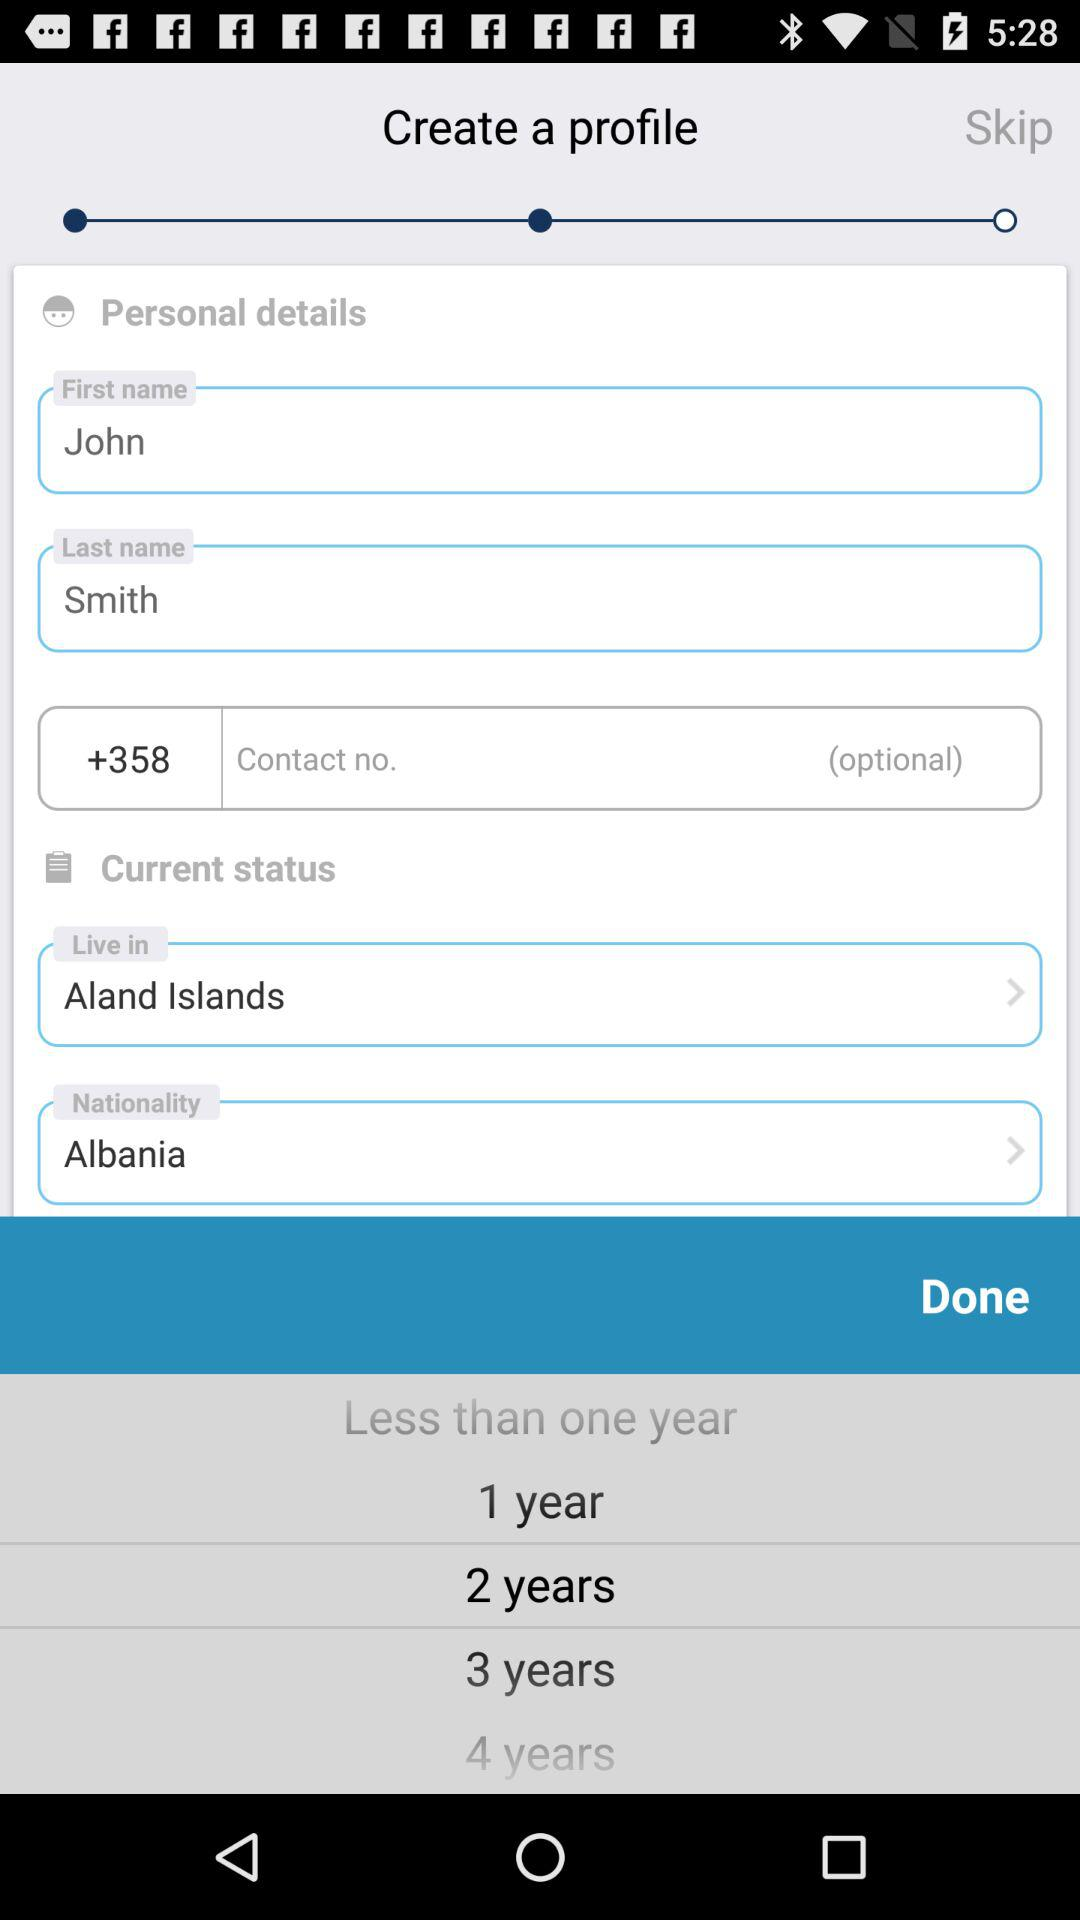What is the last name? The last name is Smith. 